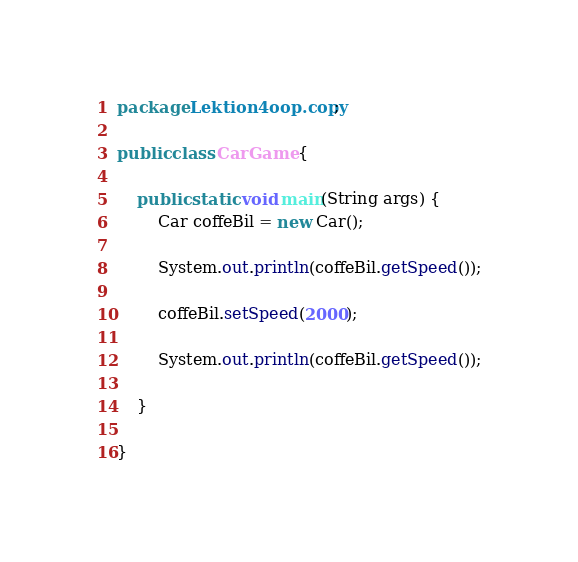<code> <loc_0><loc_0><loc_500><loc_500><_Java_>package Lektion4oop.copy;

public class CarGame {

	public static void main(String args) {
		Car coffeBil = new Car();

		System.out.println(coffeBil.getSpeed());

		coffeBil.setSpeed(2000);

		System.out.println(coffeBil.getSpeed());

	}

}</code> 